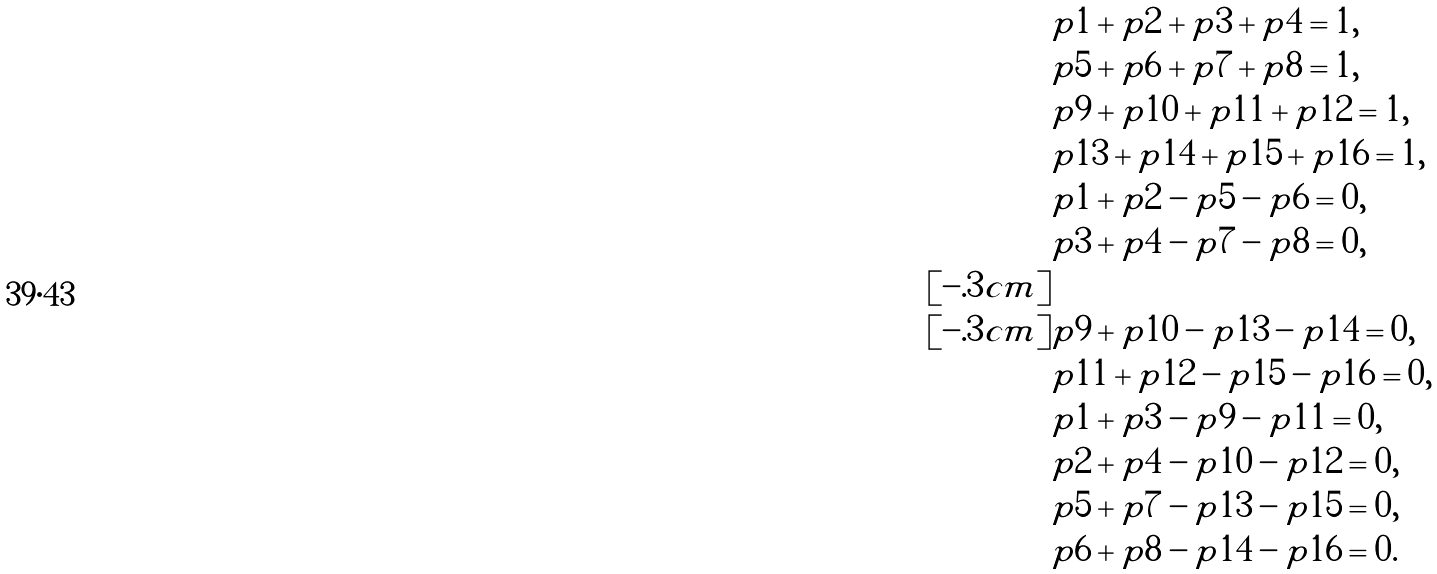Convert formula to latex. <formula><loc_0><loc_0><loc_500><loc_500>& p 1 + p 2 + p 3 + p 4 = 1 , \\ & p 5 + p 6 + p 7 + p 8 = 1 , \\ & p 9 + p 1 0 + p 1 1 + p 1 2 = 1 , \\ & p 1 3 + p 1 4 + p 1 5 + p 1 6 = 1 , \\ & p 1 + p 2 - p 5 - p 6 = 0 , \\ & p 3 + p 4 - p 7 - p 8 = 0 , \\ [ - . 3 c m ] & \\ [ - . 3 c m ] & p 9 + p 1 0 - p 1 3 - p 1 4 = 0 , \\ & p 1 1 + p 1 2 - p 1 5 - p 1 6 = 0 , \\ & p 1 + p 3 - p 9 - p 1 1 = 0 , \\ & p 2 + p 4 - p 1 0 - p 1 2 = 0 , \\ & p 5 + p 7 - p 1 3 - p 1 5 = 0 , \\ & p 6 + p 8 - p 1 4 - p 1 6 = 0 .</formula> 